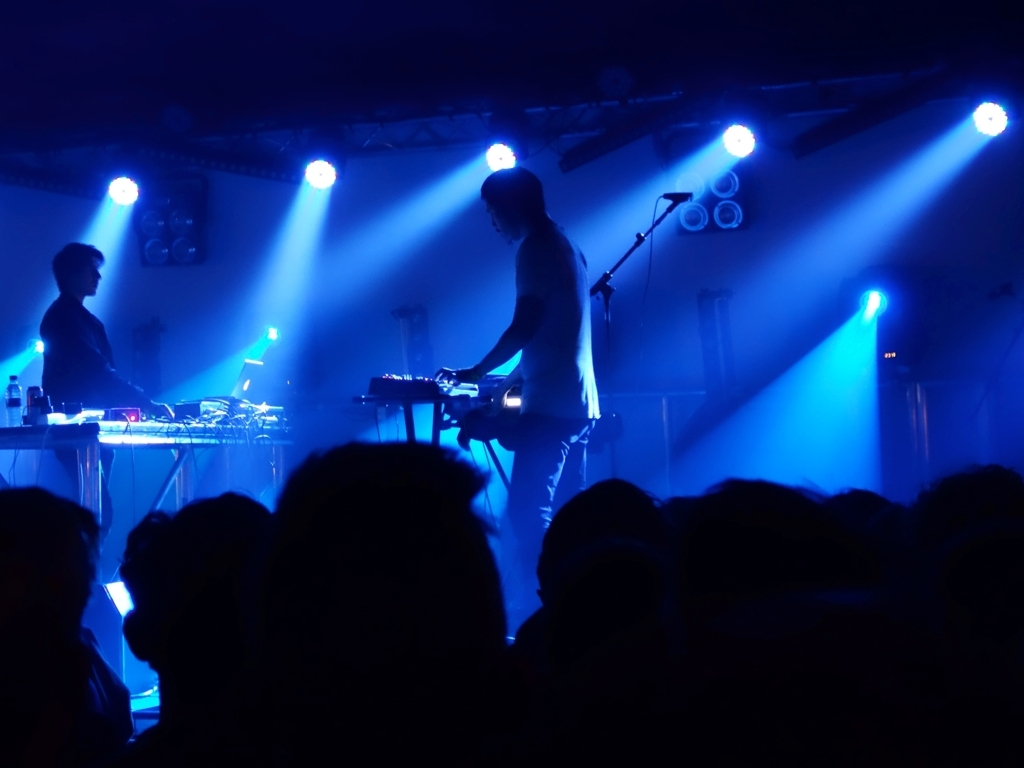Can you comment on the composition of this photo? The composition focuses on the contrast between the illuminated performers and the shadowed audience. The use of perspective draws attention to the musicians, while the cool color palette adds to the sense of depth and mood. 